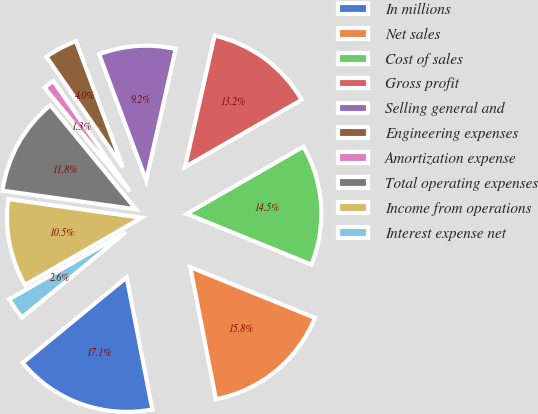<chart> <loc_0><loc_0><loc_500><loc_500><pie_chart><fcel>In millions<fcel>Net sales<fcel>Cost of sales<fcel>Gross profit<fcel>Selling general and<fcel>Engineering expenses<fcel>Amortization expense<fcel>Total operating expenses<fcel>Income from operations<fcel>Interest expense net<nl><fcel>17.1%<fcel>15.79%<fcel>14.47%<fcel>13.16%<fcel>9.21%<fcel>3.95%<fcel>1.32%<fcel>11.84%<fcel>10.53%<fcel>2.63%<nl></chart> 